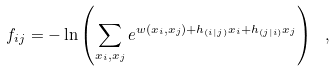<formula> <loc_0><loc_0><loc_500><loc_500>f _ { i j } = - \ln \left ( \sum _ { x _ { i } , x _ { j } } e ^ { w ( x _ { i } , x _ { j } ) + h _ { ( i | j ) } x _ { i } + h _ { ( j | i ) } x _ { j } } \right ) \ ,</formula> 